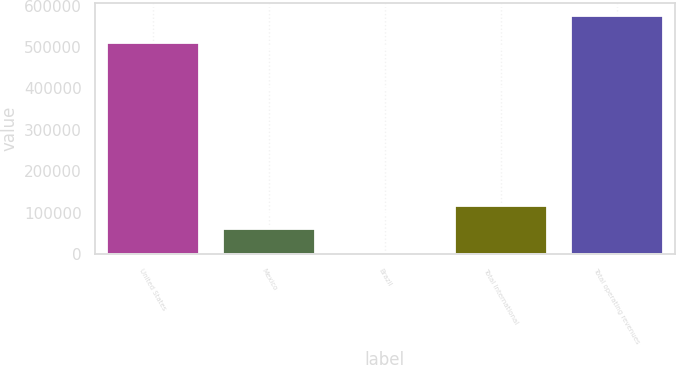Convert chart. <chart><loc_0><loc_0><loc_500><loc_500><bar_chart><fcel>United States<fcel>Mexico<fcel>Brazil<fcel>Total International<fcel>Total operating revenues<nl><fcel>512797<fcel>62280.3<fcel>5001<fcel>119560<fcel>577794<nl></chart> 